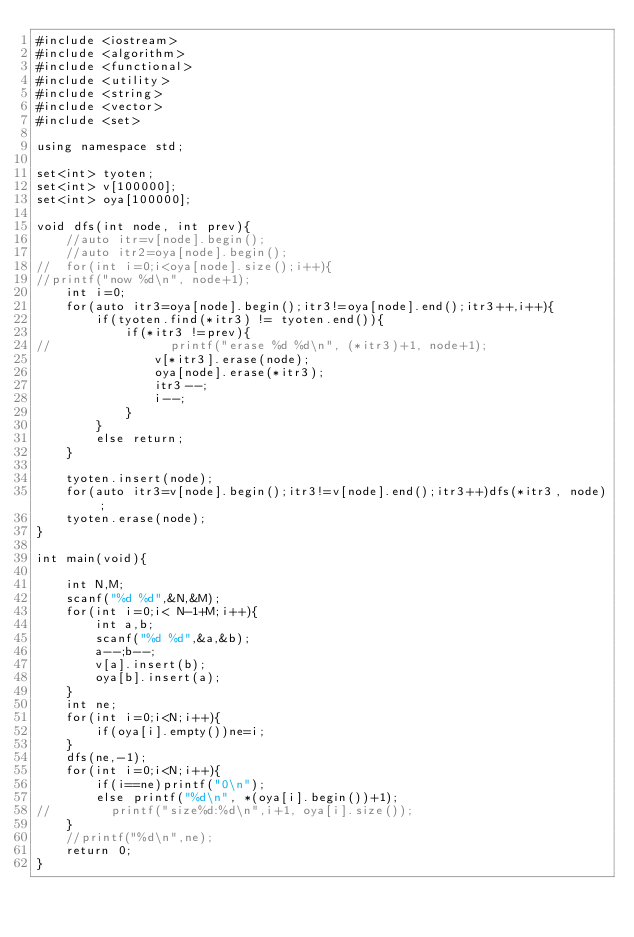<code> <loc_0><loc_0><loc_500><loc_500><_C++_>#include <iostream>
#include <algorithm>
#include <functional>
#include <utility>
#include <string>
#include <vector>
#include <set>

using namespace std;

set<int> tyoten;
set<int> v[100000];
set<int> oya[100000];

void dfs(int node, int prev){
    //auto itr=v[node].begin();
    //auto itr2=oya[node].begin();
//  for(int i=0;i<oya[node].size();i++){
//printf("now %d\n", node+1);
    int i=0;
    for(auto itr3=oya[node].begin();itr3!=oya[node].end();itr3++,i++){
        if(tyoten.find(*itr3) != tyoten.end()){
            if(*itr3 !=prev){
//                printf("erase %d %d\n", (*itr3)+1, node+1);
                v[*itr3].erase(node);
                oya[node].erase(*itr3);
                itr3--;
                i--;
            }
        }
        else return;
    }
    
    tyoten.insert(node);
    for(auto itr3=v[node].begin();itr3!=v[node].end();itr3++)dfs(*itr3, node);
    tyoten.erase(node);
}

int main(void){
    
    int N,M;
    scanf("%d %d",&N,&M);
    for(int i=0;i< N-1+M;i++){
        int a,b;
        scanf("%d %d",&a,&b);
        a--;b--;
        v[a].insert(b);
        oya[b].insert(a);
    }
    int ne;
    for(int i=0;i<N;i++){
        if(oya[i].empty())ne=i;
    }
    dfs(ne,-1);
    for(int i=0;i<N;i++){
        if(i==ne)printf("0\n");
        else printf("%d\n", *(oya[i].begin())+1);
//        printf("size%d:%d\n",i+1, oya[i].size());
    }
    //printf("%d\n",ne);
    return 0;
}</code> 